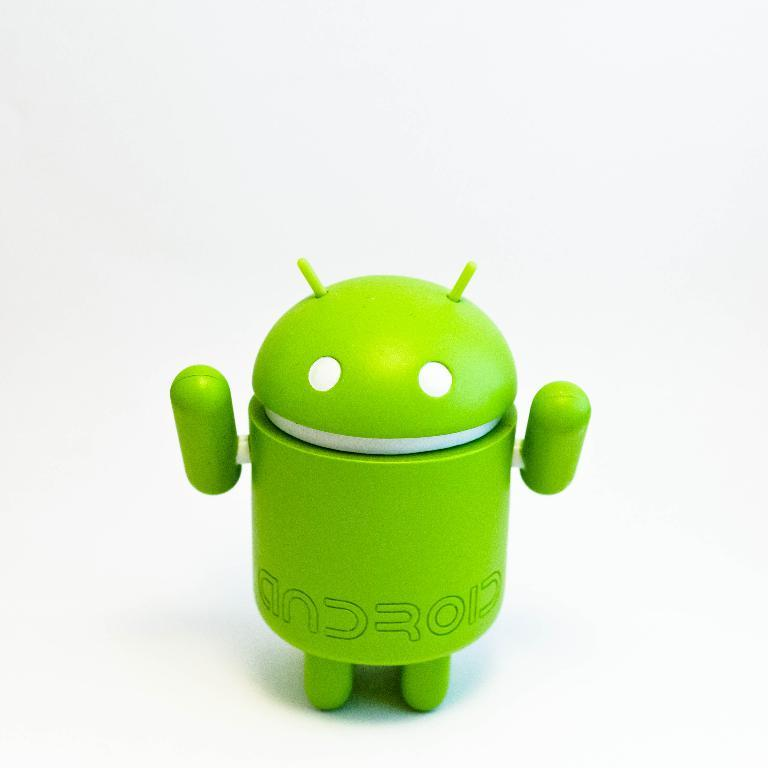<image>
Give a short and clear explanation of the subsequent image. The android green robot and it says android on the bottom of his torso. 